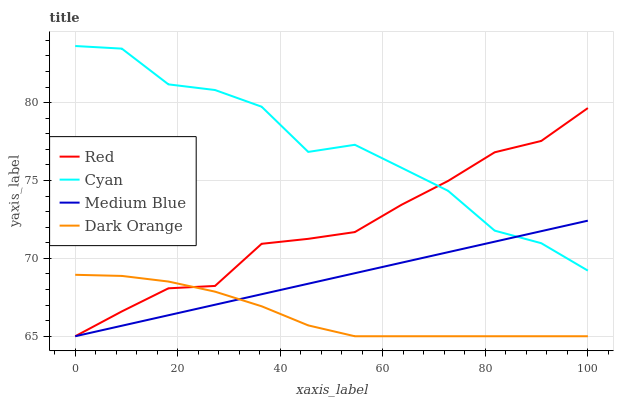Does Dark Orange have the minimum area under the curve?
Answer yes or no. Yes. Does Cyan have the maximum area under the curve?
Answer yes or no. Yes. Does Medium Blue have the minimum area under the curve?
Answer yes or no. No. Does Medium Blue have the maximum area under the curve?
Answer yes or no. No. Is Medium Blue the smoothest?
Answer yes or no. Yes. Is Cyan the roughest?
Answer yes or no. Yes. Is Red the smoothest?
Answer yes or no. No. Is Red the roughest?
Answer yes or no. No. Does Medium Blue have the lowest value?
Answer yes or no. Yes. Does Cyan have the highest value?
Answer yes or no. Yes. Does Medium Blue have the highest value?
Answer yes or no. No. Is Dark Orange less than Cyan?
Answer yes or no. Yes. Is Cyan greater than Dark Orange?
Answer yes or no. Yes. Does Red intersect Dark Orange?
Answer yes or no. Yes. Is Red less than Dark Orange?
Answer yes or no. No. Is Red greater than Dark Orange?
Answer yes or no. No. Does Dark Orange intersect Cyan?
Answer yes or no. No. 